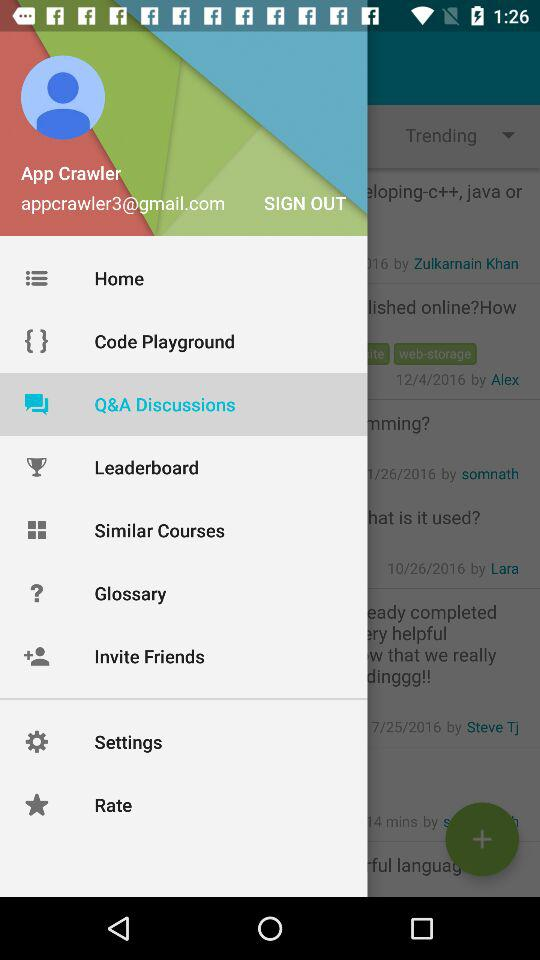What's the selected item in the menu? The selected item is "Q&A Discussions". 